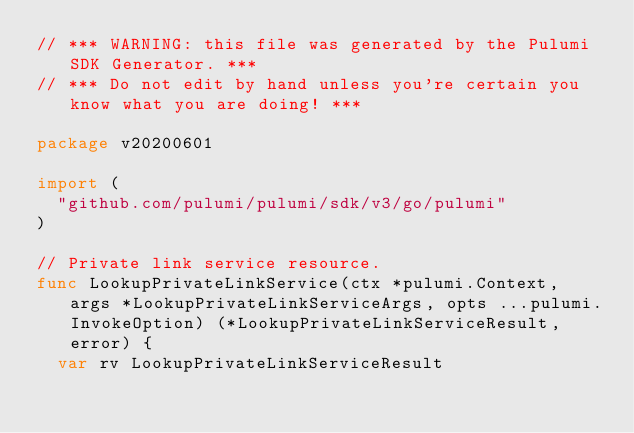<code> <loc_0><loc_0><loc_500><loc_500><_Go_>// *** WARNING: this file was generated by the Pulumi SDK Generator. ***
// *** Do not edit by hand unless you're certain you know what you are doing! ***

package v20200601

import (
	"github.com/pulumi/pulumi/sdk/v3/go/pulumi"
)

// Private link service resource.
func LookupPrivateLinkService(ctx *pulumi.Context, args *LookupPrivateLinkServiceArgs, opts ...pulumi.InvokeOption) (*LookupPrivateLinkServiceResult, error) {
	var rv LookupPrivateLinkServiceResult</code> 